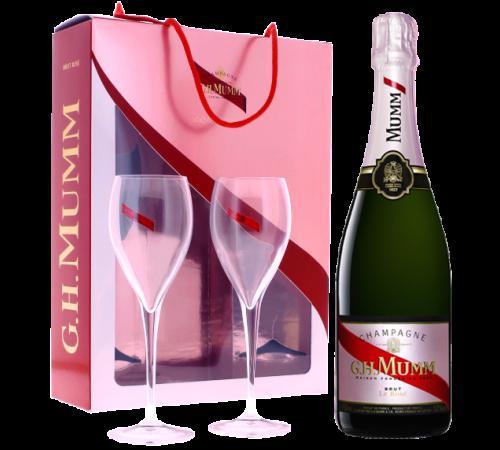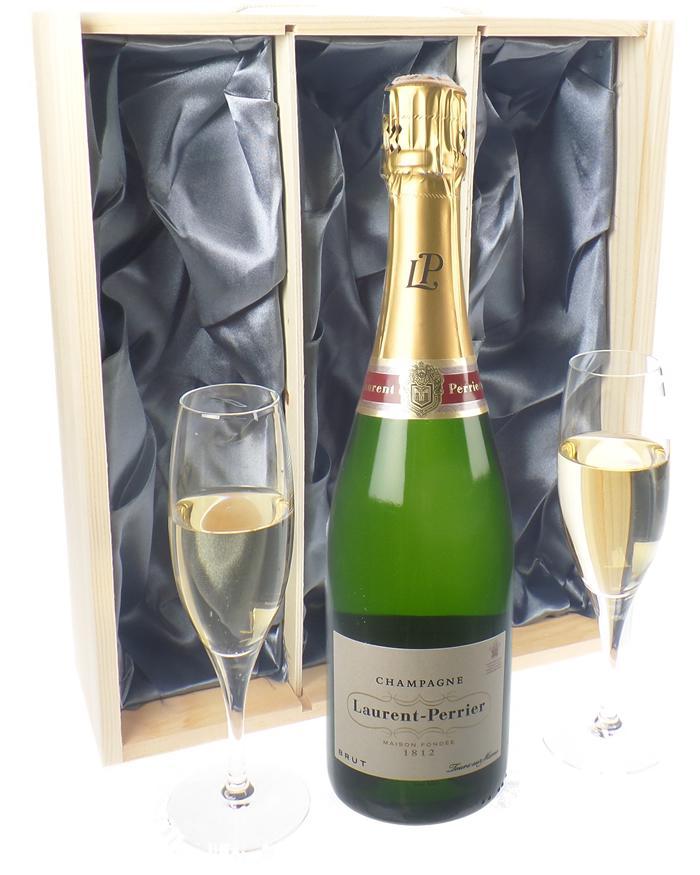The first image is the image on the left, the second image is the image on the right. Considering the images on both sides, is "Two wine glasses filled with liquid can be seen." valid? Answer yes or no. Yes. The first image is the image on the left, the second image is the image on the right. Examine the images to the left and right. Is the description "Two glasses have champagne in them." accurate? Answer yes or no. Yes. 